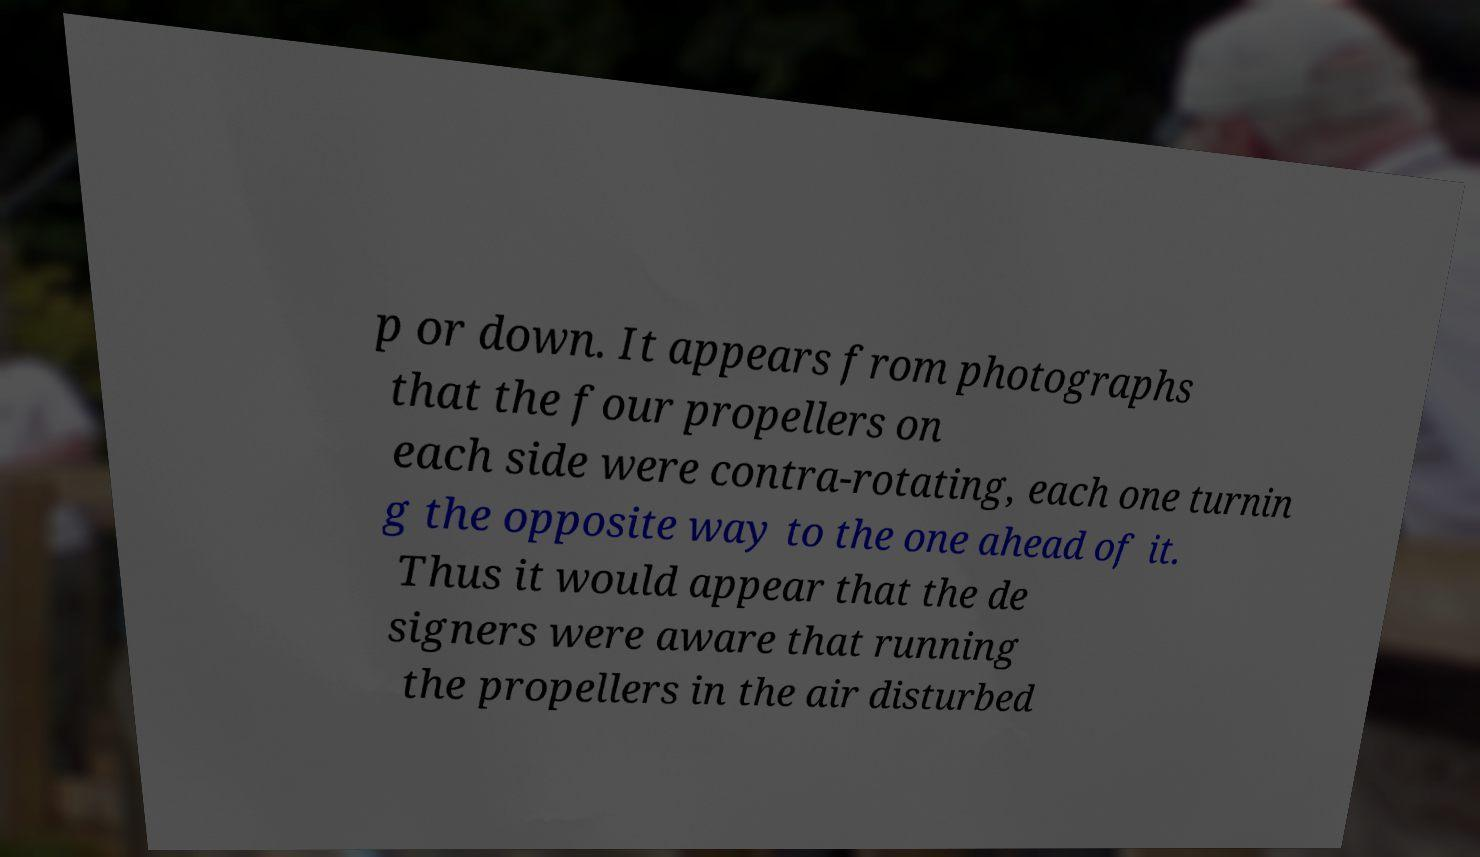I need the written content from this picture converted into text. Can you do that? p or down. It appears from photographs that the four propellers on each side were contra-rotating, each one turnin g the opposite way to the one ahead of it. Thus it would appear that the de signers were aware that running the propellers in the air disturbed 